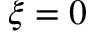Convert formula to latex. <formula><loc_0><loc_0><loc_500><loc_500>\xi = 0</formula> 